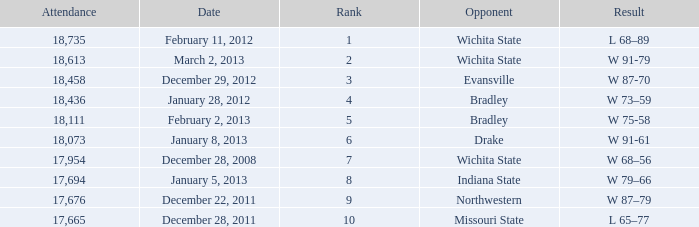When facing northwestern and the attendance is under 18,073, what rank is achieved? 9.0. 